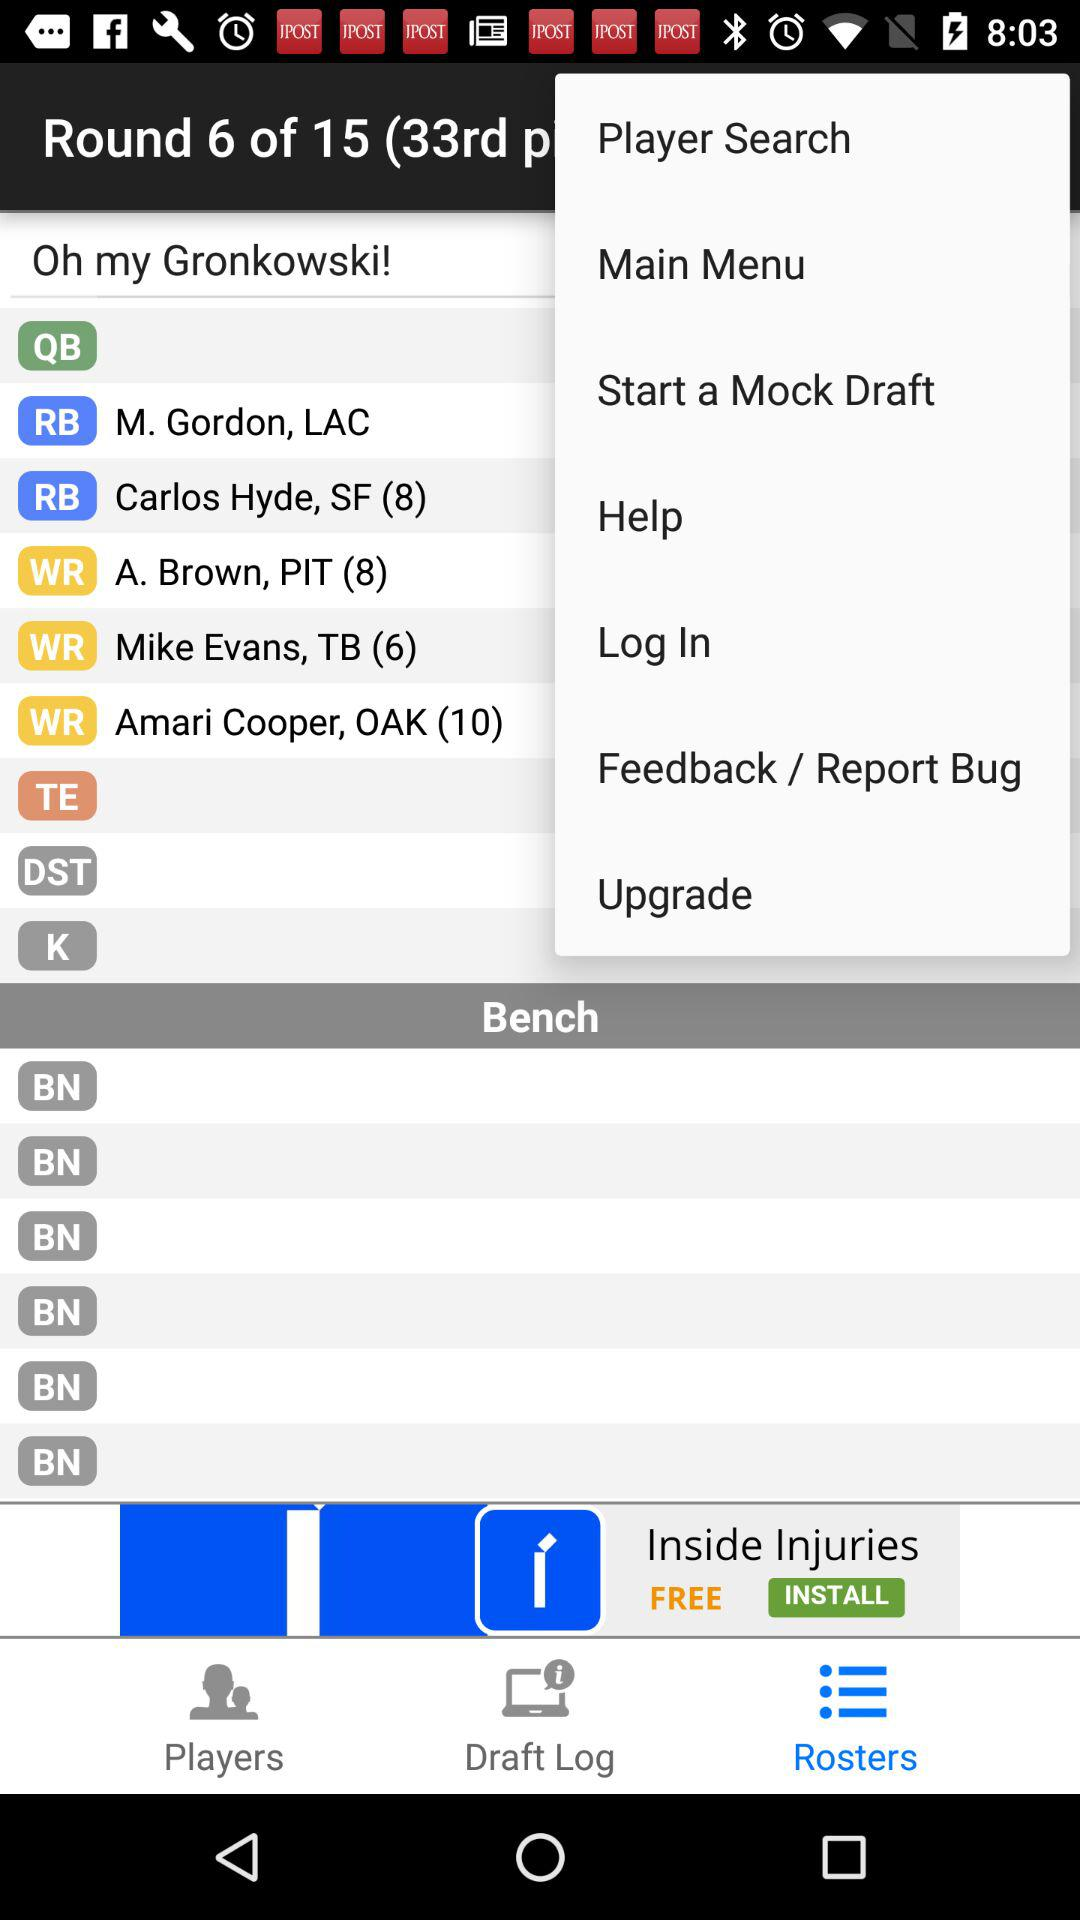Which round is the person currently in? The person is currently in round 6. 